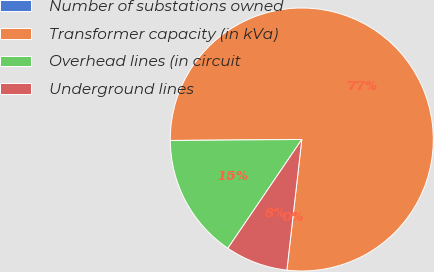<chart> <loc_0><loc_0><loc_500><loc_500><pie_chart><fcel>Number of substations owned<fcel>Transformer capacity (in kVa)<fcel>Overhead lines (in circuit<fcel>Underground lines<nl><fcel>0.0%<fcel>76.92%<fcel>15.38%<fcel>7.69%<nl></chart> 